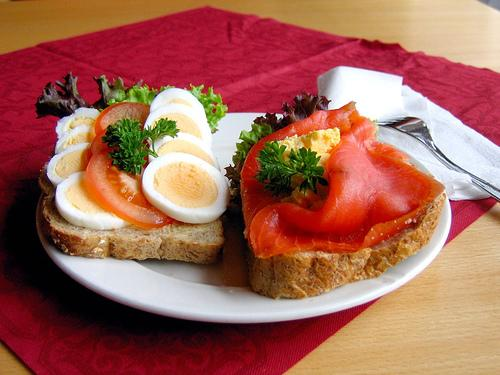Which food came from an unborn animal?

Choices:
A) meat
B) vegetables
C) eggs
D) bread eggs 